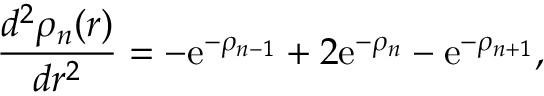<formula> <loc_0><loc_0><loc_500><loc_500>\frac { d ^ { 2 } \rho _ { n } ( r ) } { d r ^ { 2 } } = - e ^ { - \rho _ { n - 1 } } + 2 e ^ { - \rho _ { n } } - e ^ { - \rho _ { n + 1 } } ,</formula> 